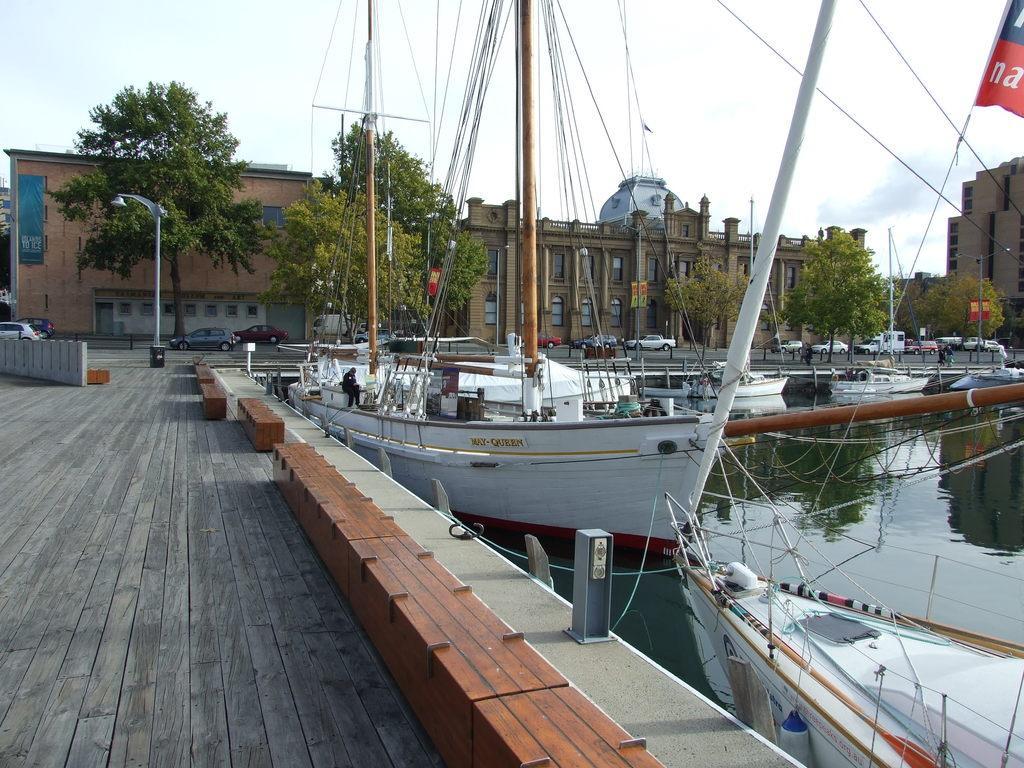Please provide a concise description of this image. On the right side of the image there are ships on the water. In the background there are buildings, poles, trees, wires and sky. At the bottom there are cars. 